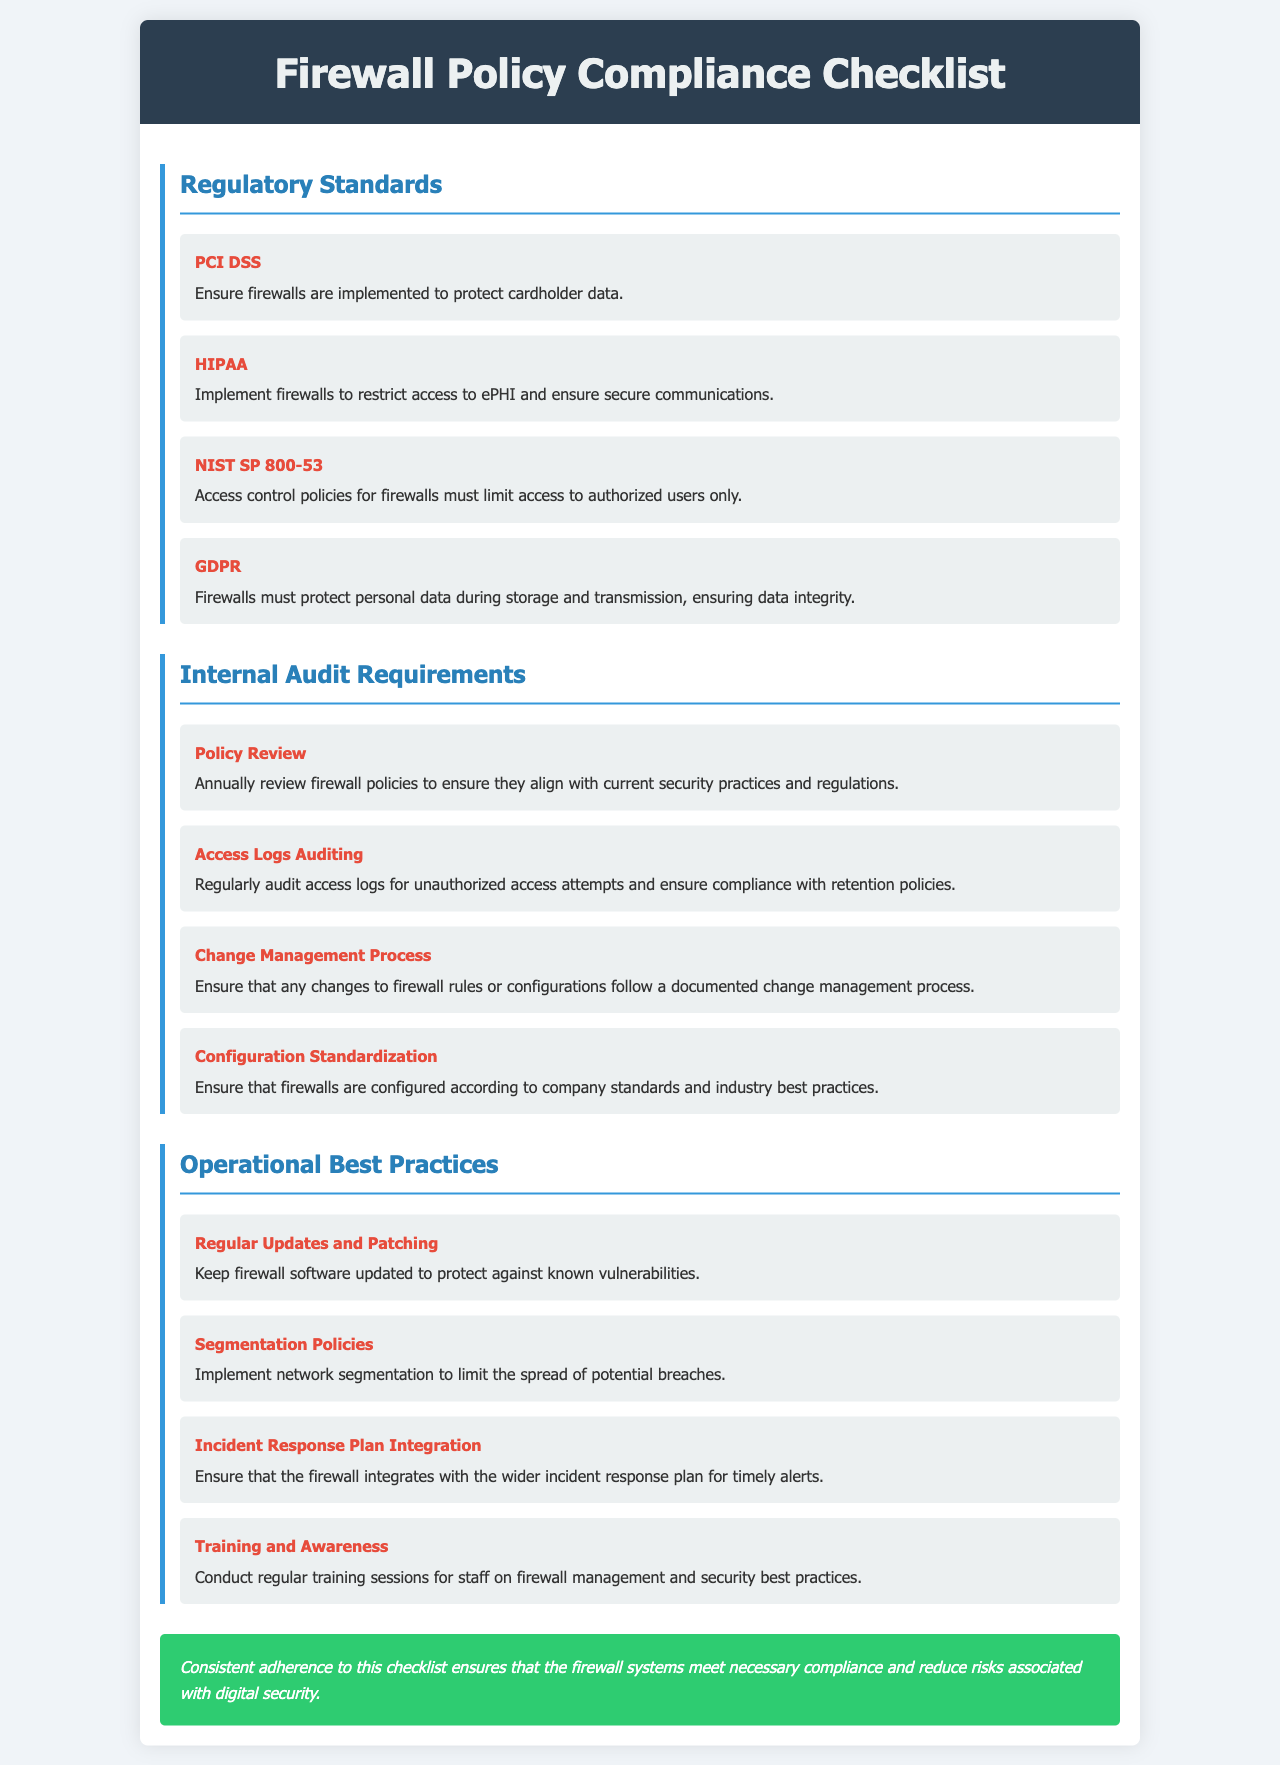what is the title of the document? The title is displayed prominently in the header of the document.
Answer: Firewall Policy Compliance Checklist how many regulatory standards are listed? The number of items in the Regulatory Standards section indicates the total regulatory standards listed.
Answer: 4 which regulatory standard focuses on protecting cardholder data? The standard that specifically addresses cardholder data is mentioned under its name and description.
Answer: PCI DSS what is the requirement for access logs auditing? The requirement is detailed within the Internal Audit Requirements section, let's locate it to answer.
Answer: Regularly audit access logs for unauthorized access attempts and ensure compliance with retention policies what does the Incident Response Plan require regarding the firewall? This is specified in the Operational Best Practices section, concerning integration with the incident response plan.
Answer: Ensure that the firewall integrates with the wider incident response plan for timely alerts how often should firewall policies be reviewed? The document states a specific timeframe for when the policies should be reviewed in the relevant section.
Answer: Annually what is the first item under Operational Best Practices? This is found by looking at the first bullet point in the Operational Best Practices section.
Answer: Regular Updates and Patching what does the GDPR firewall requirement emphasize? The essence of this requirement is captured succinctly within the Regulatory Standards section.
Answer: Protect personal data during storage and transmission, ensuring data integrity which internal audit requirement emphasizes configuration standards? This is explicitly mentioned in the Internal Audit Requirements section under its respective heading.
Answer: Configuration Standardization 